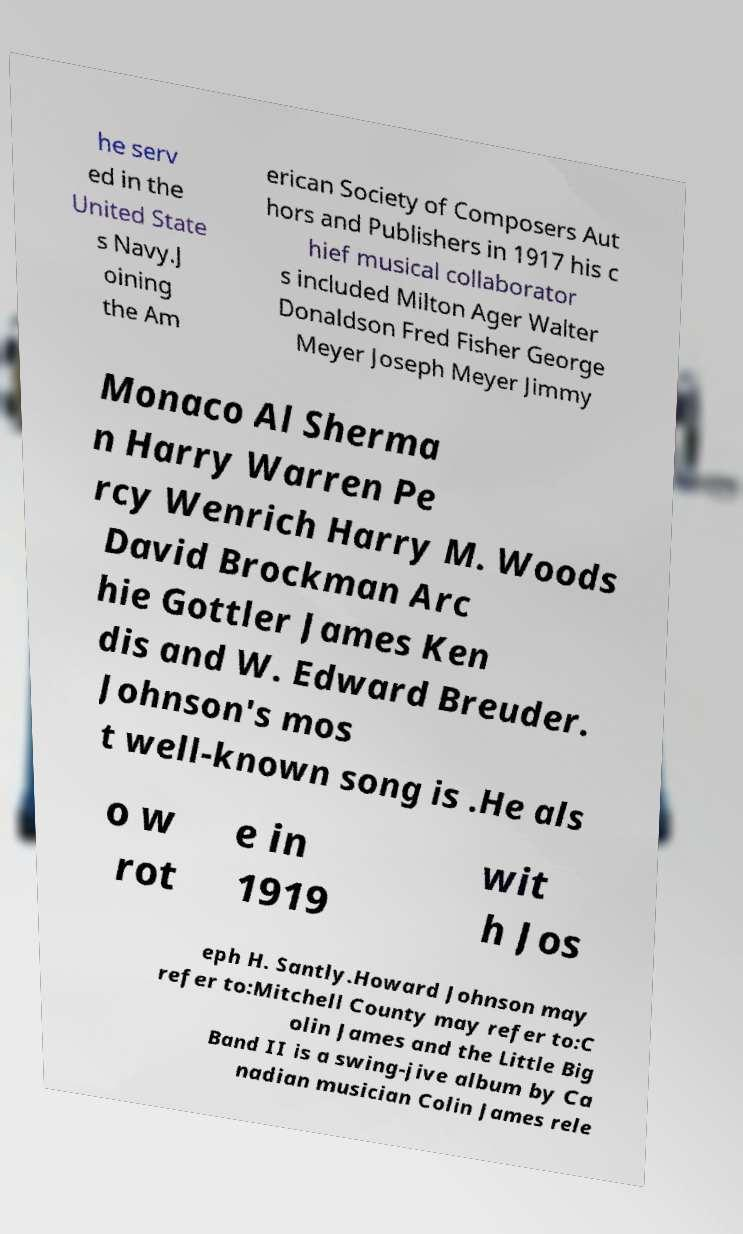Can you accurately transcribe the text from the provided image for me? he serv ed in the United State s Navy.J oining the Am erican Society of Composers Aut hors and Publishers in 1917 his c hief musical collaborator s included Milton Ager Walter Donaldson Fred Fisher George Meyer Joseph Meyer Jimmy Monaco Al Sherma n Harry Warren Pe rcy Wenrich Harry M. Woods David Brockman Arc hie Gottler James Ken dis and W. Edward Breuder. Johnson's mos t well-known song is .He als o w rot e in 1919 wit h Jos eph H. Santly.Howard Johnson may refer to:Mitchell County may refer to:C olin James and the Little Big Band II is a swing-jive album by Ca nadian musician Colin James rele 